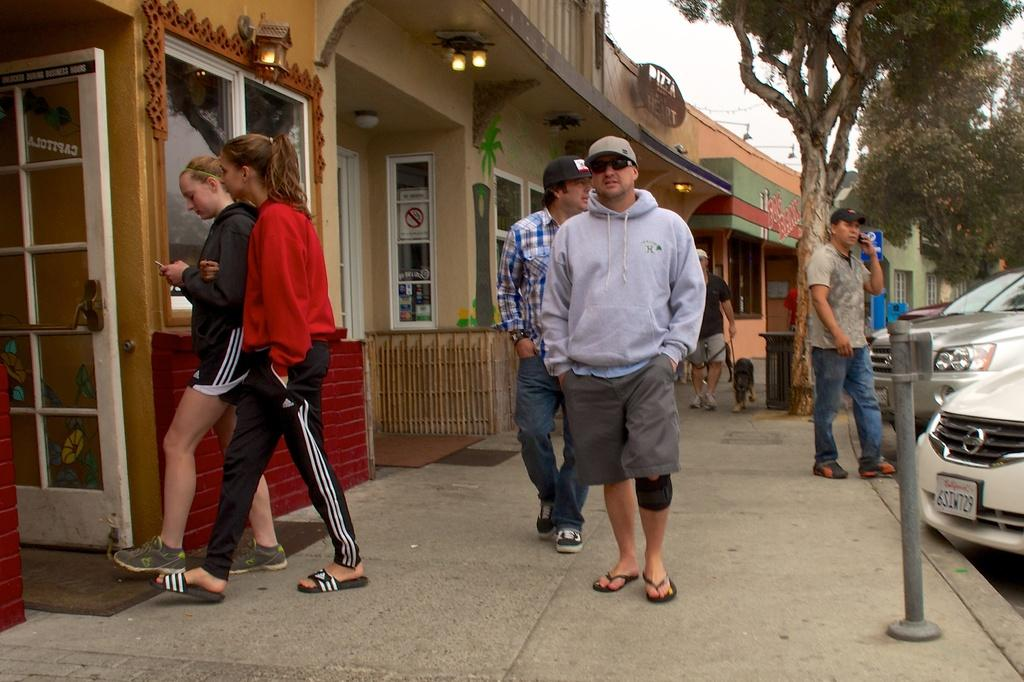What can be seen on the path in the image? There are people on the path in the image. What type of establishments are located on the left side of the image? There are stores on the left side of the image. What is visible in the background of the image? There are trees in the background of the image. What is present on the right side of the image? There are cars on the right side of the image. How does the trail of authority increase in the image? There is no trail of authority present in the image; it features people on a path, stores, trees, and cars. What type of trail can be seen in the image? There is no trail visible in the image; it features a path with people on it. 